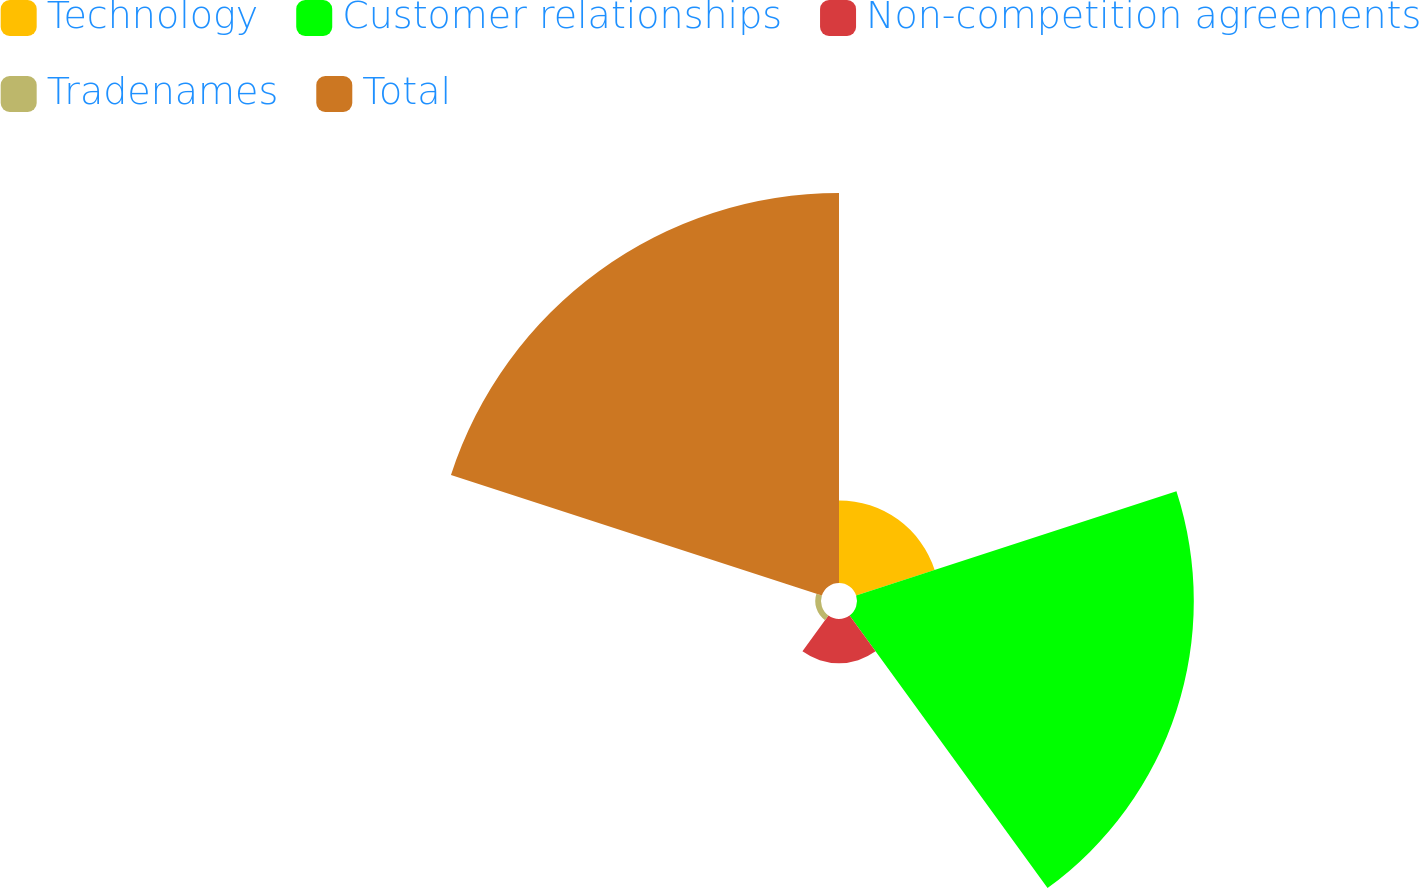Convert chart to OTSL. <chart><loc_0><loc_0><loc_500><loc_500><pie_chart><fcel>Technology<fcel>Customer relationships<fcel>Non-competition agreements<fcel>Tradenames<fcel>Total<nl><fcel>9.61%<fcel>39.19%<fcel>5.14%<fcel>0.67%<fcel>45.38%<nl></chart> 